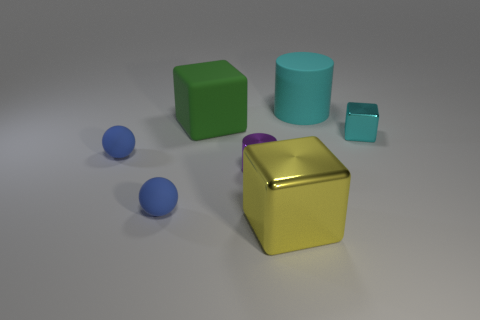Subtract all blue cylinders. Subtract all brown spheres. How many cylinders are left? 2 Add 3 large yellow metal things. How many objects exist? 10 Subtract all cubes. How many objects are left? 4 Add 1 small brown metal cylinders. How many small brown metal cylinders exist? 1 Subtract 0 green cylinders. How many objects are left? 7 Subtract all tiny blue balls. Subtract all small cylinders. How many objects are left? 4 Add 1 small cyan metal things. How many small cyan metal things are left? 2 